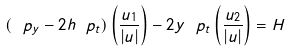<formula> <loc_0><loc_0><loc_500><loc_500>( \ p _ { y } - 2 h \ p _ { t } ) \left ( \frac { u _ { 1 } } { | u | } \right ) - 2 y \ p _ { t } \left ( \frac { u _ { 2 } } { | u | } \right ) = H</formula> 